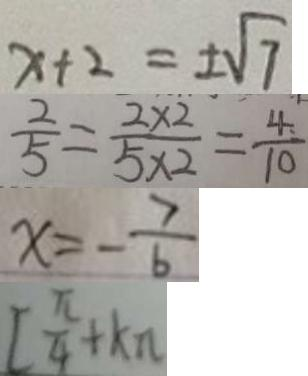<formula> <loc_0><loc_0><loc_500><loc_500>x + 2 = \pm \sqrt { 7 } 
 \frac { 2 } { 5 } = \frac { 2 \times 2 } { 5 \times 2 } = \frac { 4 } { 1 0 } 
 x = - \frac { 7 } { 6 } 
 [ \frac { \pi } { 4 } + k \pi</formula> 